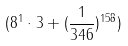<formula> <loc_0><loc_0><loc_500><loc_500>( 8 ^ { 1 } \cdot 3 + ( \frac { 1 } { 3 4 6 } ) ^ { 1 5 8 } )</formula> 